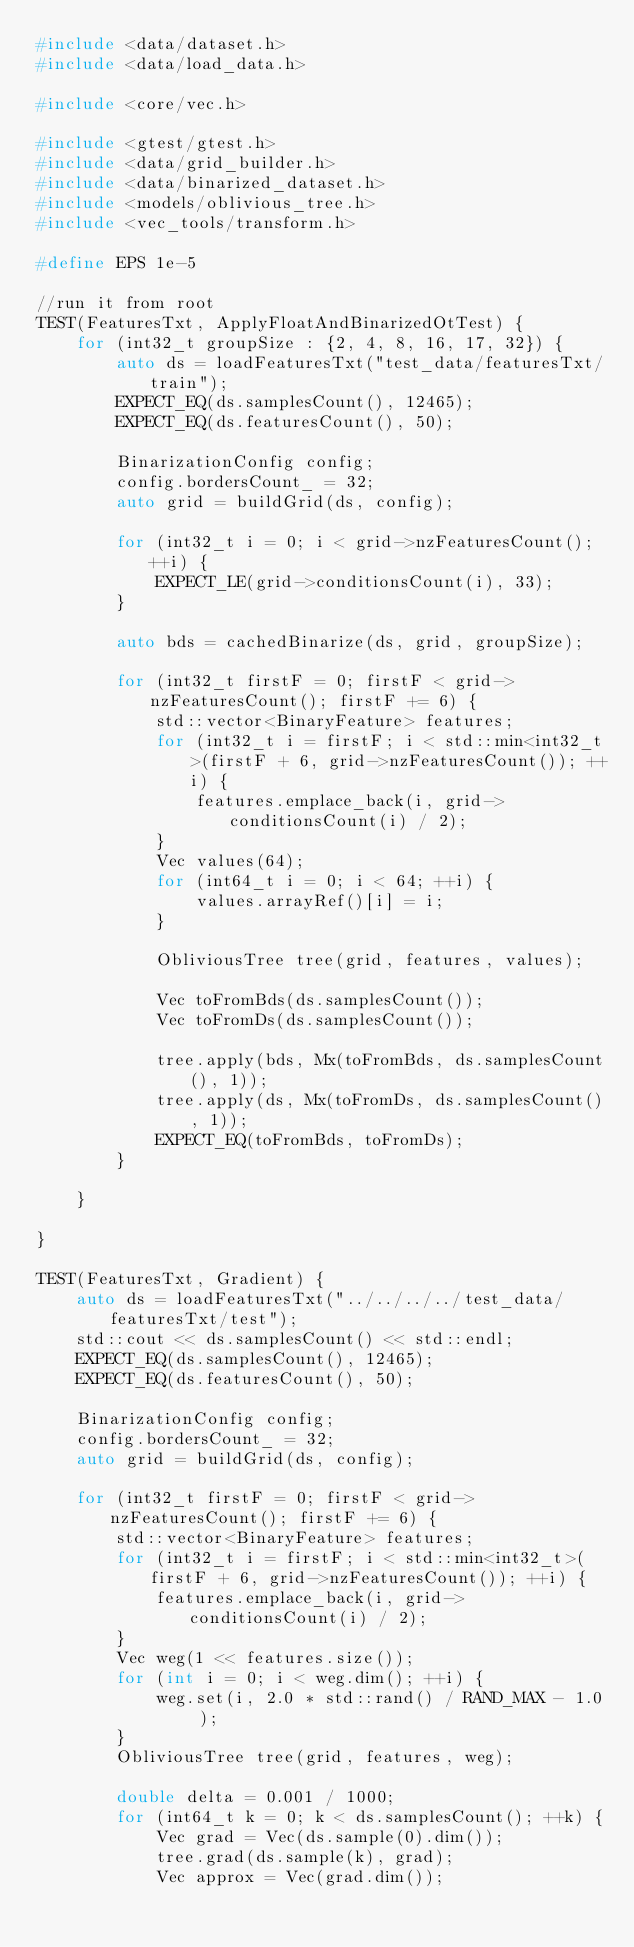<code> <loc_0><loc_0><loc_500><loc_500><_C++_>#include <data/dataset.h>
#include <data/load_data.h>

#include <core/vec.h>

#include <gtest/gtest.h>
#include <data/grid_builder.h>
#include <data/binarized_dataset.h>
#include <models/oblivious_tree.h>
#include <vec_tools/transform.h>

#define EPS 1e-5

//run it from root
TEST(FeaturesTxt, ApplyFloatAndBinarizedOtTest) {
    for (int32_t groupSize : {2, 4, 8, 16, 17, 32}) {
        auto ds = loadFeaturesTxt("test_data/featuresTxt/train");
        EXPECT_EQ(ds.samplesCount(), 12465);
        EXPECT_EQ(ds.featuresCount(), 50);

        BinarizationConfig config;
        config.bordersCount_ = 32;
        auto grid = buildGrid(ds, config);

        for (int32_t i = 0; i < grid->nzFeaturesCount(); ++i) {
            EXPECT_LE(grid->conditionsCount(i), 33);
        }

        auto bds = cachedBinarize(ds, grid, groupSize);

        for (int32_t firstF = 0; firstF < grid->nzFeaturesCount(); firstF += 6) {
            std::vector<BinaryFeature> features;
            for (int32_t i = firstF; i < std::min<int32_t>(firstF + 6, grid->nzFeaturesCount()); ++i) {
                features.emplace_back(i, grid->conditionsCount(i) / 2);
            }
            Vec values(64);
            for (int64_t i = 0; i < 64; ++i) {
                values.arrayRef()[i] = i;
            }

            ObliviousTree tree(grid, features, values);

            Vec toFromBds(ds.samplesCount());
            Vec toFromDs(ds.samplesCount());

            tree.apply(bds, Mx(toFromBds, ds.samplesCount(), 1));
            tree.apply(ds, Mx(toFromDs, ds.samplesCount(), 1));
            EXPECT_EQ(toFromBds, toFromDs);
        }

    }

}

TEST(FeaturesTxt, Gradient) {
    auto ds = loadFeaturesTxt("../../../../test_data/featuresTxt/test");
    std::cout << ds.samplesCount() << std::endl;
    EXPECT_EQ(ds.samplesCount(), 12465);
    EXPECT_EQ(ds.featuresCount(), 50);

    BinarizationConfig config;
    config.bordersCount_ = 32;
    auto grid = buildGrid(ds, config);

    for (int32_t firstF = 0; firstF < grid->nzFeaturesCount(); firstF += 6) {
        std::vector<BinaryFeature> features;
        for (int32_t i = firstF; i < std::min<int32_t>(firstF + 6, grid->nzFeaturesCount()); ++i) {
            features.emplace_back(i, grid->conditionsCount(i) / 2);
        }
        Vec weg(1 << features.size());
        for (int i = 0; i < weg.dim(); ++i) {
            weg.set(i, 2.0 * std::rand() / RAND_MAX - 1.0 );
        }
        ObliviousTree tree(grid, features, weg);

        double delta = 0.001 / 1000;
        for (int64_t k = 0; k < ds.samplesCount(); ++k) {
            Vec grad = Vec(ds.sample(0).dim());
            tree.grad(ds.sample(k), grad);
            Vec approx = Vec(grad.dim());</code> 